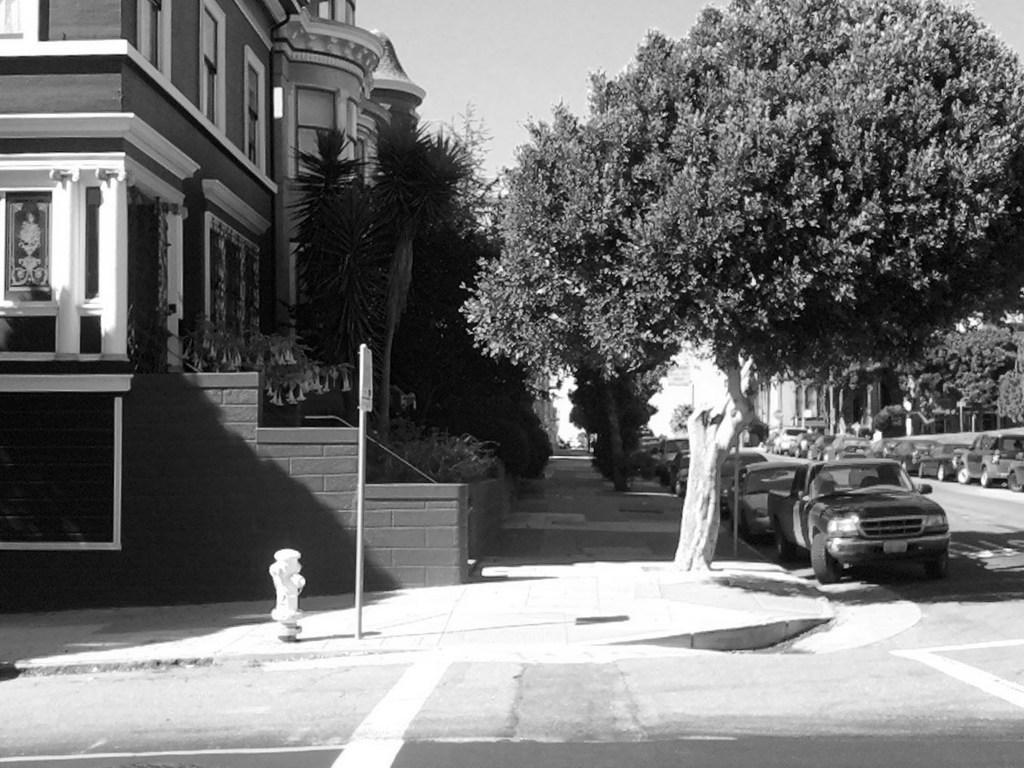Describe this image in one or two sentences. This picture shows a buildings and we see trees and cars parked on the roads. 